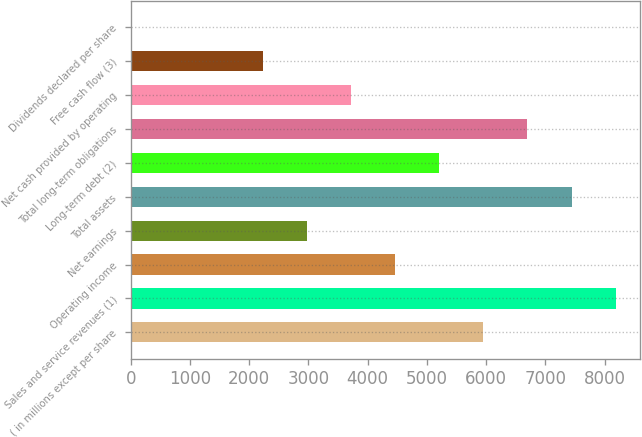Convert chart to OTSL. <chart><loc_0><loc_0><loc_500><loc_500><bar_chart><fcel>( in millions except per share<fcel>Sales and service revenues (1)<fcel>Operating income<fcel>Net earnings<fcel>Total assets<fcel>Long-term debt (2)<fcel>Total long-term obligations<fcel>Net cash provided by operating<fcel>Free cash flow (3)<fcel>Dividends declared per share<nl><fcel>5953.32<fcel>8184.87<fcel>4465.62<fcel>2977.92<fcel>7441.02<fcel>5209.47<fcel>6697.17<fcel>3721.77<fcel>2234.07<fcel>2.52<nl></chart> 